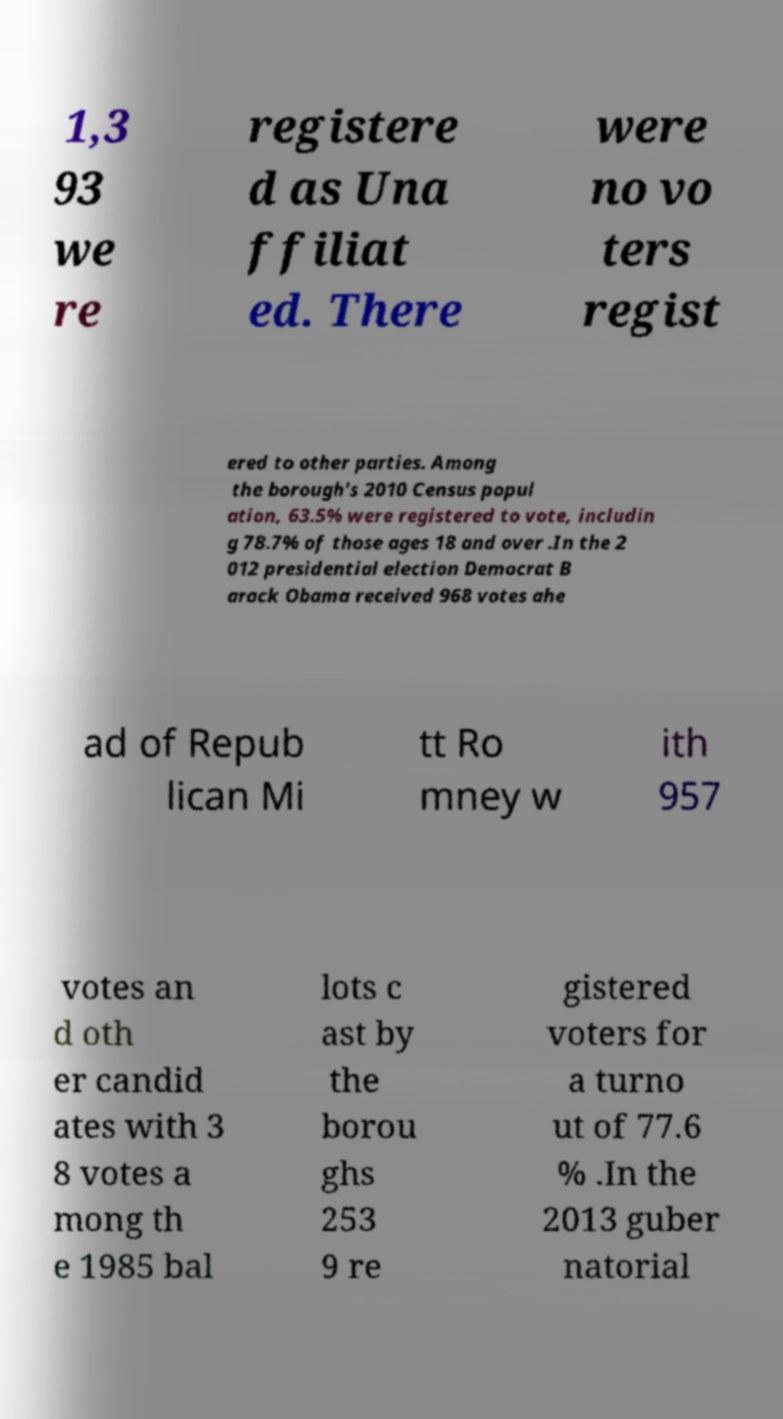Could you extract and type out the text from this image? 1,3 93 we re registere d as Una ffiliat ed. There were no vo ters regist ered to other parties. Among the borough's 2010 Census popul ation, 63.5% were registered to vote, includin g 78.7% of those ages 18 and over .In the 2 012 presidential election Democrat B arack Obama received 968 votes ahe ad of Repub lican Mi tt Ro mney w ith 957 votes an d oth er candid ates with 3 8 votes a mong th e 1985 bal lots c ast by the borou ghs 253 9 re gistered voters for a turno ut of 77.6 % .In the 2013 guber natorial 